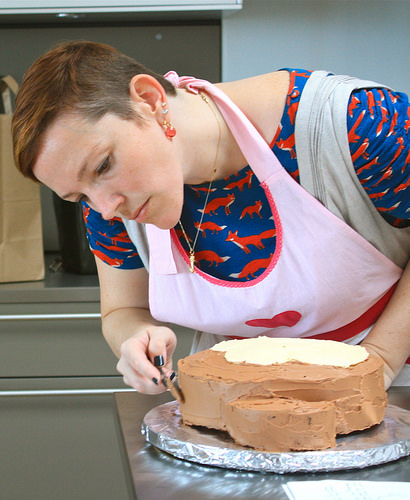<image>
Is there a knife on the counter? No. The knife is not positioned on the counter. They may be near each other, but the knife is not supported by or resting on top of the counter. Is there a apron on the cake? No. The apron is not positioned on the cake. They may be near each other, but the apron is not supported by or resting on top of the cake. 